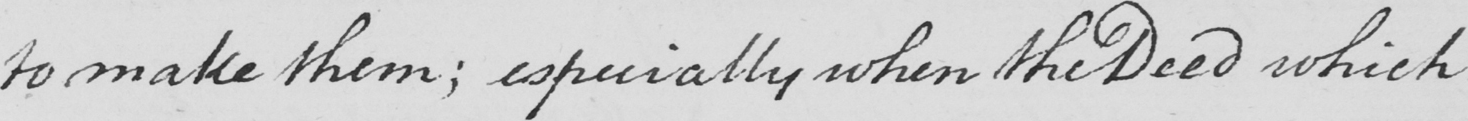What does this handwritten line say? to make them ; especially when the Deed which 